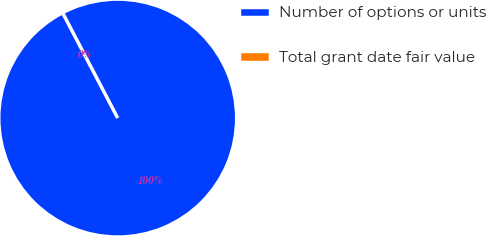Convert chart. <chart><loc_0><loc_0><loc_500><loc_500><pie_chart><fcel>Number of options or units<fcel>Total grant date fair value<nl><fcel>100.0%<fcel>0.0%<nl></chart> 